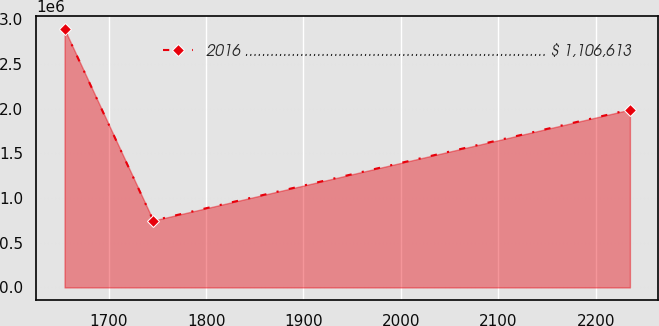Convert chart. <chart><loc_0><loc_0><loc_500><loc_500><line_chart><ecel><fcel>2016 ....................................................................... $ 1,106,613<nl><fcel>1654.74<fcel>2.88713e+06<nl><fcel>1745.81<fcel>748019<nl><fcel>2235.06<fcel>1.98831e+06<nl></chart> 